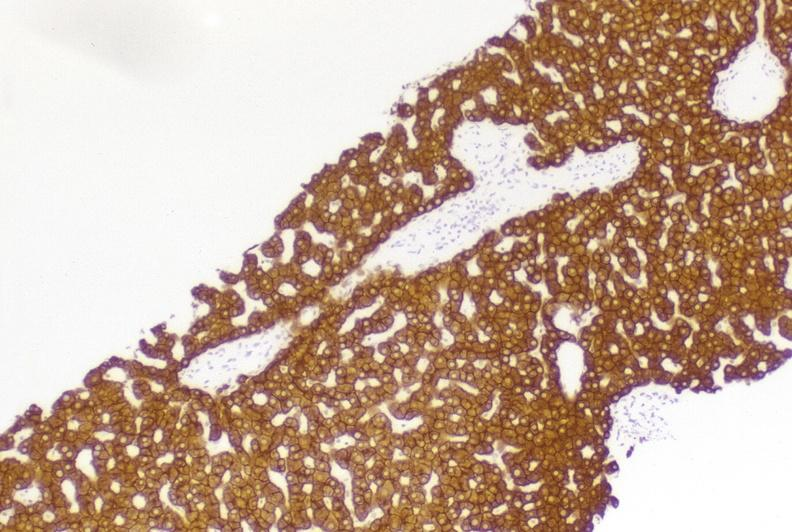s liver present?
Answer the question using a single word or phrase. Yes 